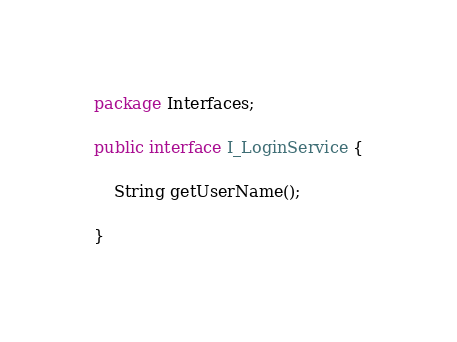Convert code to text. <code><loc_0><loc_0><loc_500><loc_500><_Java_>package Interfaces;

public interface I_LoginService {
	
	String getUserName();

}
</code> 